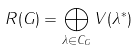Convert formula to latex. <formula><loc_0><loc_0><loc_500><loc_500>R ( G ) = \bigoplus _ { \lambda \in C _ { G } } V ( \lambda ^ { * } )</formula> 